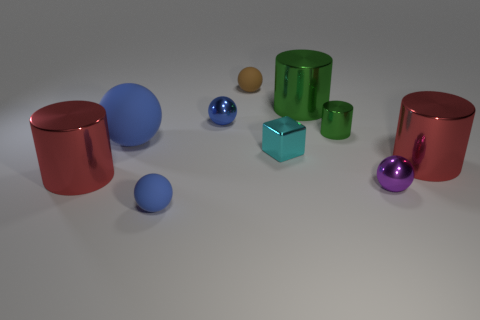How many blue balls must be subtracted to get 1 blue balls? 2 Subtract all purple cylinders. How many blue balls are left? 3 Subtract 1 cylinders. How many cylinders are left? 3 Subtract all brown balls. How many balls are left? 4 Subtract all small brown spheres. How many spheres are left? 4 Subtract all green spheres. Subtract all gray cylinders. How many spheres are left? 5 Subtract all blocks. How many objects are left? 9 Add 6 blue matte balls. How many blue matte balls are left? 8 Add 7 large red matte objects. How many large red matte objects exist? 7 Subtract 0 green blocks. How many objects are left? 10 